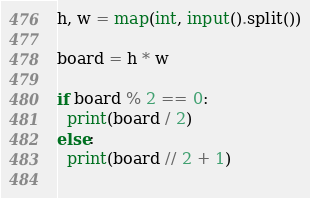Convert code to text. <code><loc_0><loc_0><loc_500><loc_500><_Python_>h, w = map(int, input().split())

board = h * w

if board % 2 == 0:
  print(board / 2)
else:
  print(board // 2 + 1)
  </code> 